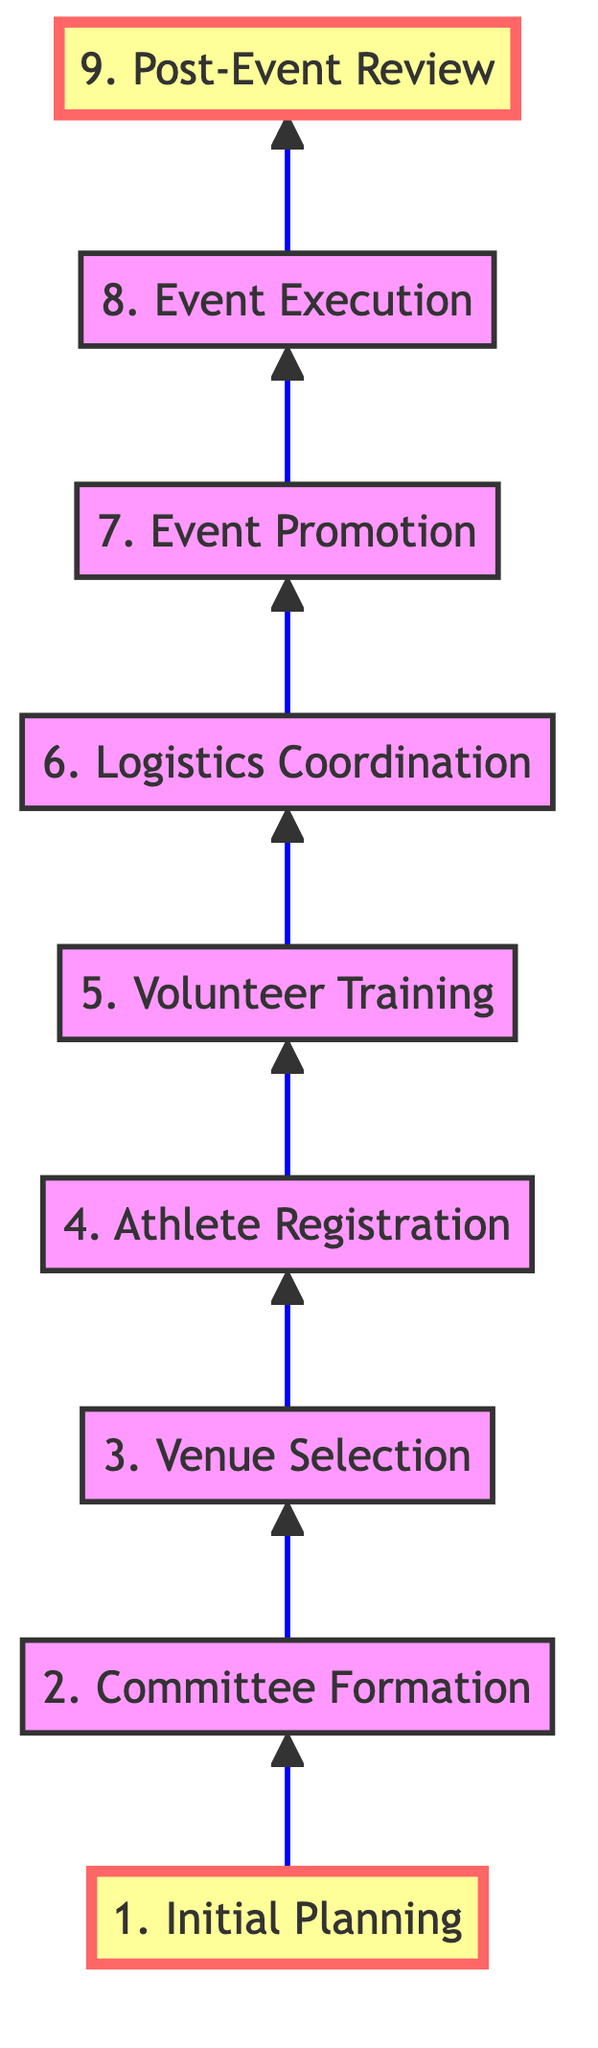What is the first step in organizing a Special Olympics event? The diagram starts with the first node labeled "1. Initial Planning," which clearly specifies it as the initial step in the process.
Answer: 1. Initial Planning How many steps are listed in the diagram? By counting the nodes in the flow chart, there are a total of nine steps, from "1. Initial Planning" to "9. Post-Event Review."
Answer: 9 What follows "5. Volunteer Training" in the flow chart? The diagram shows that "6. Logistics Coordination" directly follows "5. Volunteer Training," indicating the subsequent step in the organizational process.
Answer: 6. Logistics Coordination What is the last step in organizing the event? According to the flow chart, the last node is labeled "9. Post-Event Review," which indicates the concluding step after the event execution.
Answer: 9. Post-Event Review Which step involves securing the venue? The third step in the flow chart is labeled "3. Venue Selection," and it specifically focuses on identifying and securing a suitable location for the event.
Answer: 3. Venue Selection Explain the relationship between "Event Execution" and "Event Promotion." "Event Promotion" is positioned just before "Event Execution" in the flow chart, indicating that promoting the event happens prior to its execution, creating a clear sequence for organizing the event.
Answer: Event Promotion comes before Event Execution Is there a step that deals with athlete registration? Yes, the diagram includes "4. Athlete Registration," which explicitly addresses the process related to registering athletes for the event.
Answer: 4. Athlete Registration What is required before the event can be executed? Before the event can be executed, "5. Volunteer Training" must take place, as indicated by its position directly before "8. Event Execution" in the flow chart.
Answer: 5. Volunteer Training Which of the steps focuses on evaluating outcomes post-event? The final step labeled "9. Post-Event Review" focuses on evaluating and gathering feedback on the event outcomes after it has taken place.
Answer: 9. Post-Event Review 